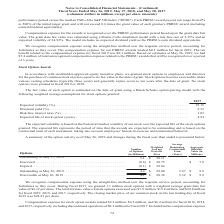According to Conagra Brands's financial document, What was the compensation expense for stock option awards during the fiscal year 2018? According to the financial document, $4.2 million. The relevant text states: "ense for stock option awards totaled $2.2 million, $4.2 million, and $6.2 million for fiscal 2019, 2018,..." Also, What was the weighted average fair value per share for stock options granted during 2017? According to the financial document, $6.12. The relevant text states: "s with a weighted average grant date fair value of $6.12 per share. The total intrinsic value of stock options exercised was $7.9 million, $15.8 million, and..." Also, How many options were exercisable as of May 26, 2019? According to the financial document, 4.1 (in millions). The relevant text states: "Exercisable at May 26, 2019 . 4.1 $ 28.38 5.32 $ 9.9..." Also, can you calculate: What is the percentage change in the number of outstanding options from 2018 to 2019? To answer this question, I need to perform calculations using the financial data. The calculation is: (4.4-5.1)/5.1 , which equals -13.73 (percentage). This is based on the information: "Outstanding at May 27, 2018. . 5.1 $ 28.11 Outstanding at May 26, 2019. . 4.4 $ 29.00 5.47 $ 9.9..." The key data points involved are: 4.4, 5.1. Also, can you calculate: What is the proportion of exercisable options over outstanding options as of May 26, 2019? Based on the calculation: 4.1 / 4.4 , the result is 0.93. This is based on the information: "Exercisable at May 26, 2019 . 4.1 $ 28.38 5.32 $ 9.9 Outstanding at May 26, 2019. . 4.4 $ 29.00 5.47 $ 9.9..." The key data points involved are: 4.1, 4.4. Also, can you calculate: What is the total price of exercised and expired options? Based on the calculation: (0.6*20.75)+(0.1*29.84) , the result is 15.43 (in millions). This is based on the information: "Exercised . (0.6) $ 20.75 $ 7.9 to the compensation expense for fiscal 2019 was $0.1 million. Based on estimates at May 26, 2019, we had $7.4 million of total unrecognized compensation Exercised . (0...." The key data points involved are: 0.1, 0.6, 20.75. 